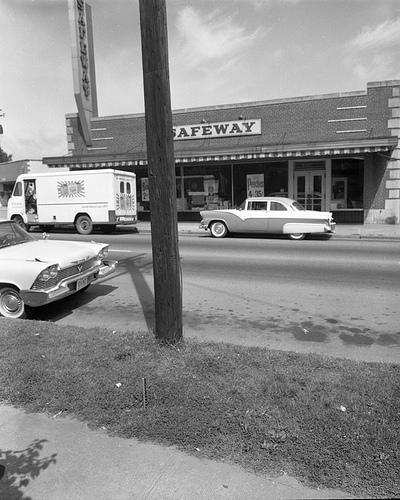How many cars are in the picture?
Give a very brief answer. 3. How many cars are there?
Give a very brief answer. 2. How many chairs are in this room?
Give a very brief answer. 0. 